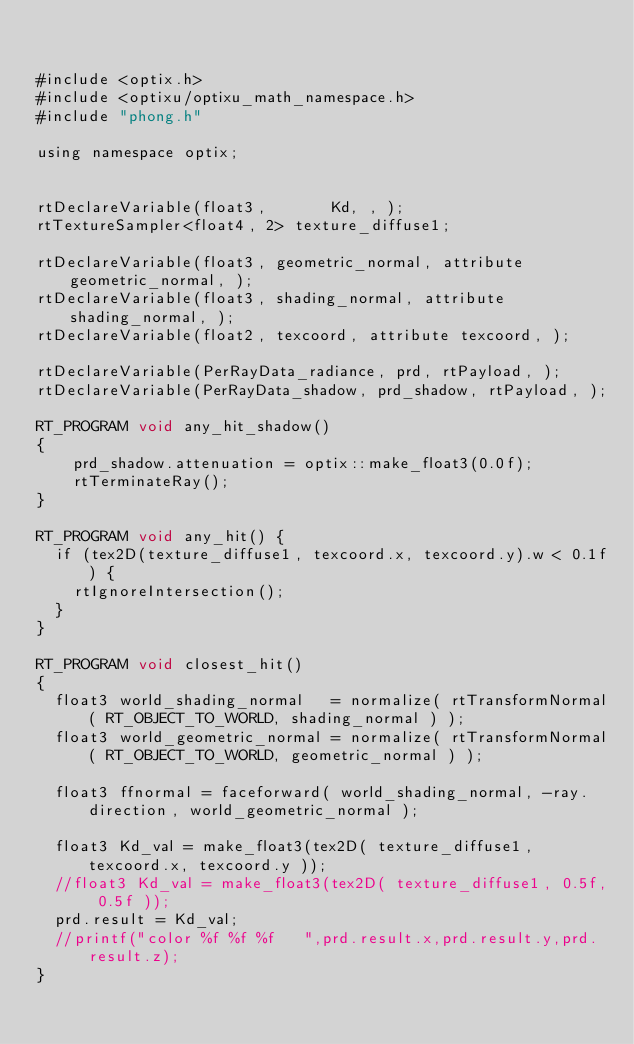Convert code to text. <code><loc_0><loc_0><loc_500><loc_500><_Cuda_>

#include <optix.h>
#include <optixu/optixu_math_namespace.h>
#include "phong.h"

using namespace optix;


rtDeclareVariable(float3,       Kd, , );
rtTextureSampler<float4, 2> texture_diffuse1;

rtDeclareVariable(float3, geometric_normal, attribute geometric_normal, ); 
rtDeclareVariable(float3, shading_normal, attribute shading_normal, ); 
rtDeclareVariable(float2, texcoord, attribute texcoord, ); 

rtDeclareVariable(PerRayData_radiance, prd, rtPayload, );
rtDeclareVariable(PerRayData_shadow, prd_shadow, rtPayload, );

RT_PROGRAM void any_hit_shadow()
{
	prd_shadow.attenuation = optix::make_float3(0.0f);
	rtTerminateRay();
}

RT_PROGRAM void any_hit() {
  if (tex2D(texture_diffuse1, texcoord.x, texcoord.y).w < 0.1f) {
    rtIgnoreIntersection();
  } 
}

RT_PROGRAM void closest_hit()
{
  float3 world_shading_normal   = normalize( rtTransformNormal( RT_OBJECT_TO_WORLD, shading_normal ) );
  float3 world_geometric_normal = normalize( rtTransformNormal( RT_OBJECT_TO_WORLD, geometric_normal ) );

  float3 ffnormal = faceforward( world_shading_normal, -ray.direction, world_geometric_normal );

  float3 Kd_val = make_float3(tex2D( texture_diffuse1, texcoord.x, texcoord.y ));
  //float3 Kd_val = make_float3(tex2D( texture_diffuse1, 0.5f, 0.5f ));
  prd.result = Kd_val;
  //printf("color %f %f %f   ",prd.result.x,prd.result.y,prd.result.z);
}


</code> 